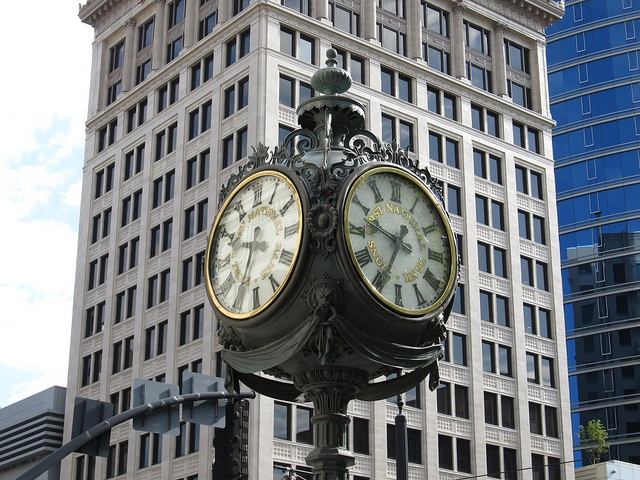Describe the objects in this image and their specific colors. I can see clock in white, darkgray, gray, black, and olive tones, clock in white, lightgray, darkgray, beige, and gray tones, and potted plant in white, black, darkgreen, and gray tones in this image. 